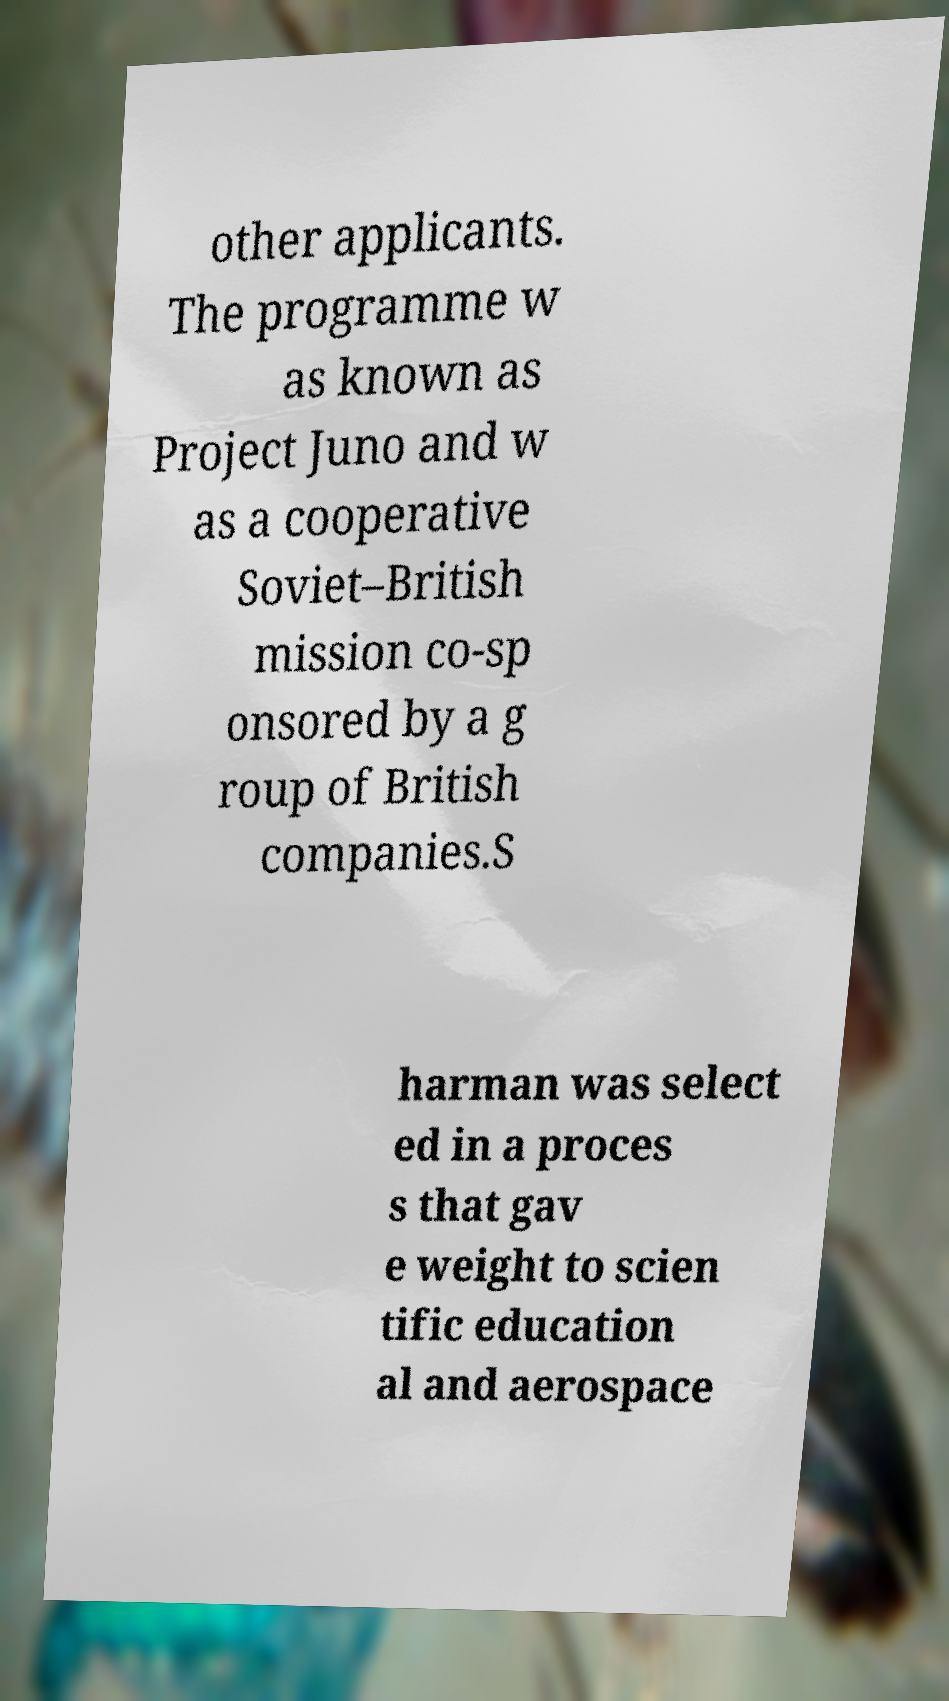Can you accurately transcribe the text from the provided image for me? other applicants. The programme w as known as Project Juno and w as a cooperative Soviet–British mission co-sp onsored by a g roup of British companies.S harman was select ed in a proces s that gav e weight to scien tific education al and aerospace 